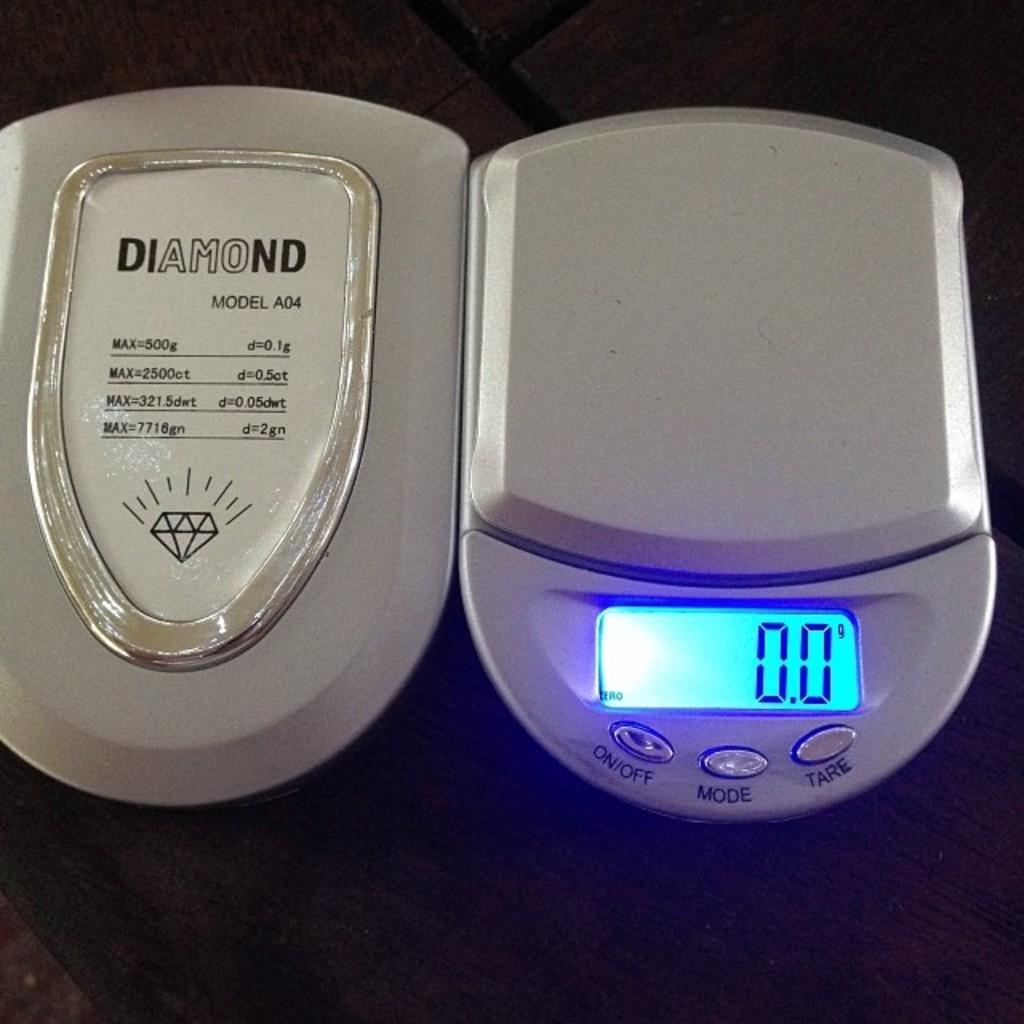<image>
Offer a succinct explanation of the picture presented. A Diamond brand weight read 0.0 on the scale 